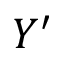Convert formula to latex. <formula><loc_0><loc_0><loc_500><loc_500>Y ^ { \prime }</formula> 